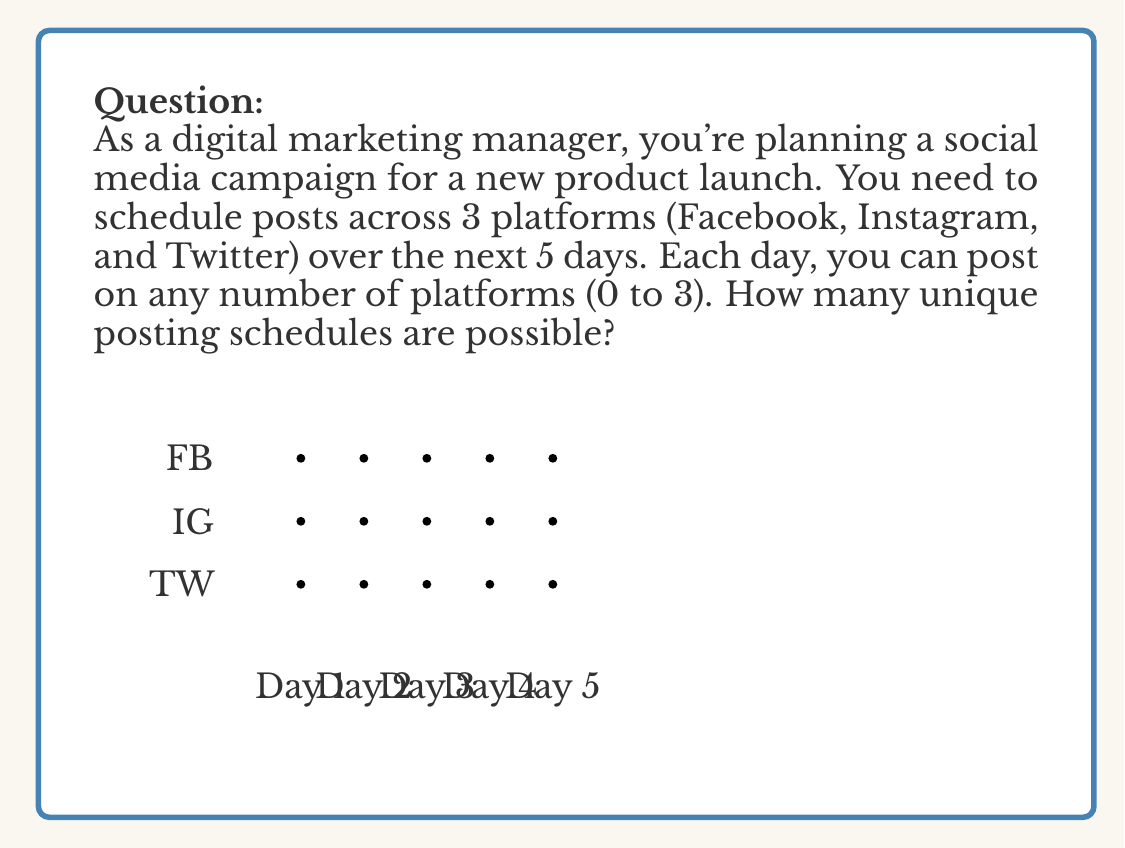Teach me how to tackle this problem. Let's approach this step-by-step:

1) For each day, we have 4 possibilities:
   - Post on no platform
   - Post on 1 platform (3 ways)
   - Post on 2 platforms (3 ways)
   - Post on all 3 platforms

2) This means for each day, we have $1 + 3 + 3 + 1 = 8$ choices.

3) We need to make this choice for each of the 5 days.

4) According to the multiplication principle, if we have a series of independent choices, the total number of possibilities is the product of the number of possibilities for each choice.

5) Therefore, the total number of unique posting schedules is:

   $$ 8 \times 8 \times 8 \times 8 \times 8 = 8^5 $$

6) Calculating this:
   $$ 8^5 = 32,768 $$

This large number demonstrates the importance of strategic planning in digital marketing, as the number of possibilities can quickly become overwhelming.
Answer: $32,768$ 